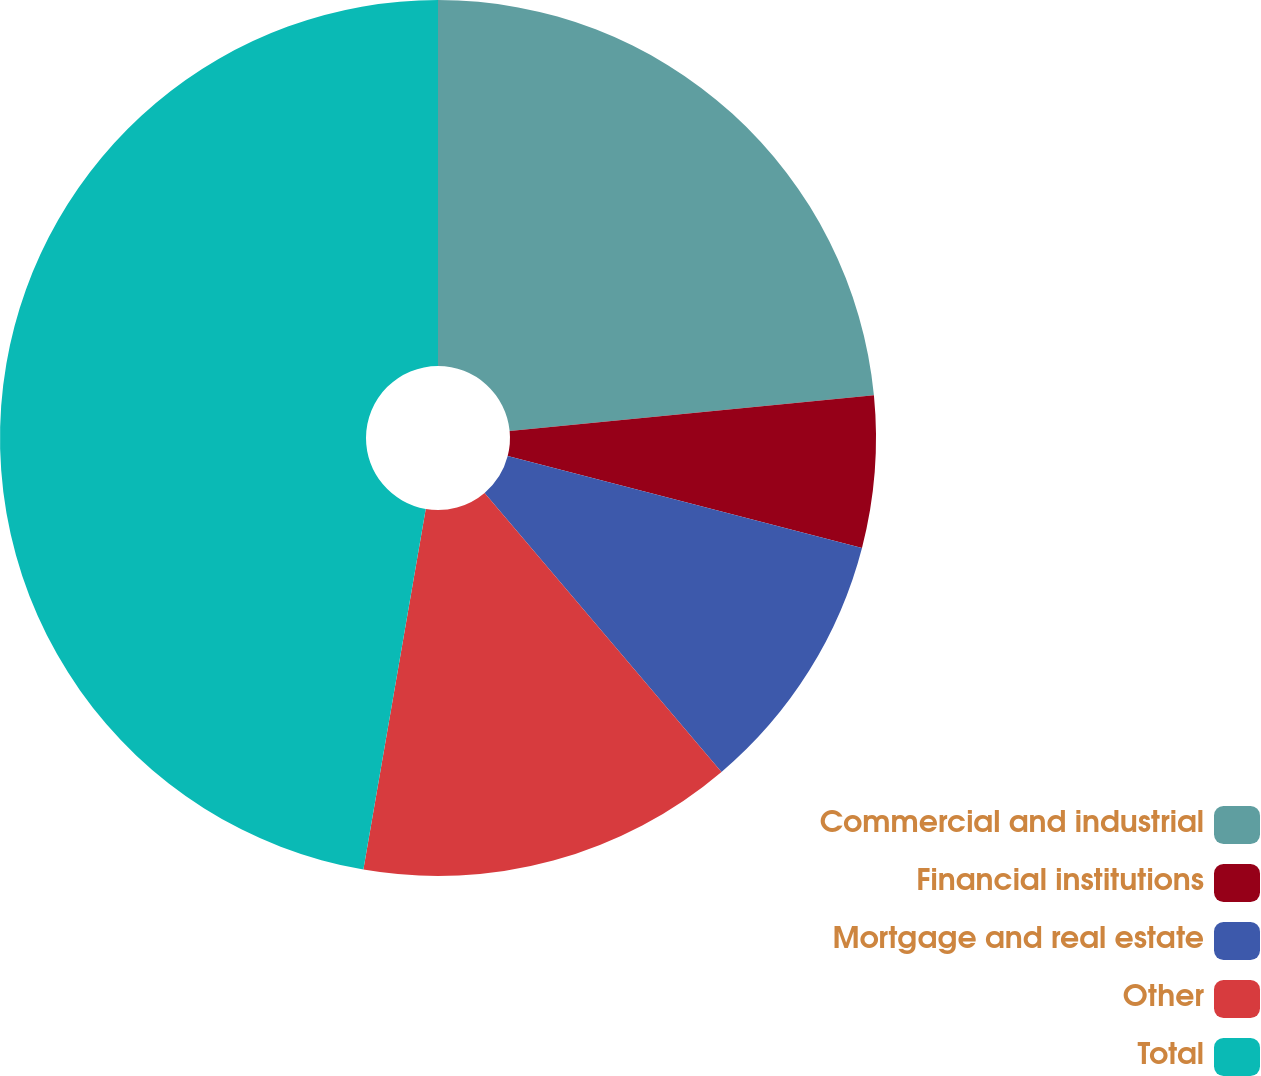Convert chart to OTSL. <chart><loc_0><loc_0><loc_500><loc_500><pie_chart><fcel>Commercial and industrial<fcel>Financial institutions<fcel>Mortgage and real estate<fcel>Other<fcel>Total<nl><fcel>23.45%<fcel>5.59%<fcel>9.76%<fcel>13.93%<fcel>47.28%<nl></chart> 